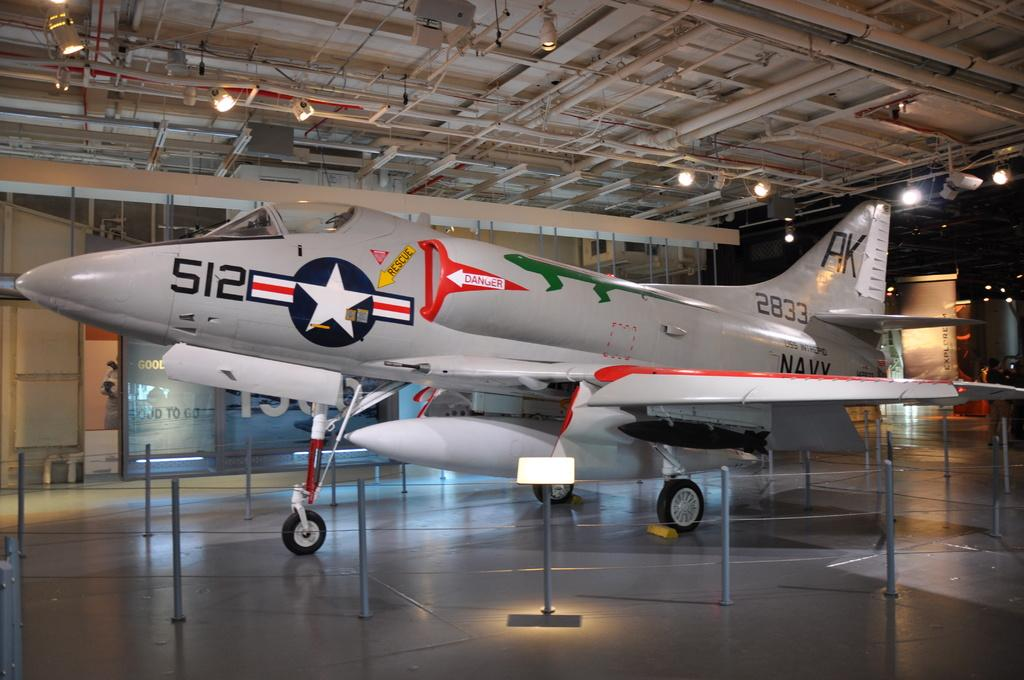<image>
Describe the image concisely. A plane displayed in a museum with the number 512 on it. 